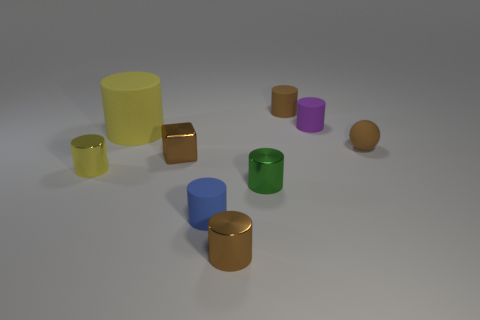Subtract all purple cylinders. How many cylinders are left? 6 Subtract all yellow shiny cylinders. How many cylinders are left? 6 Subtract all gray cylinders. Subtract all blue balls. How many cylinders are left? 7 Add 1 small purple matte spheres. How many objects exist? 10 Subtract all balls. How many objects are left? 8 Add 8 big yellow cylinders. How many big yellow cylinders are left? 9 Add 7 yellow cylinders. How many yellow cylinders exist? 9 Subtract 0 purple cubes. How many objects are left? 9 Subtract all big matte cylinders. Subtract all small things. How many objects are left? 0 